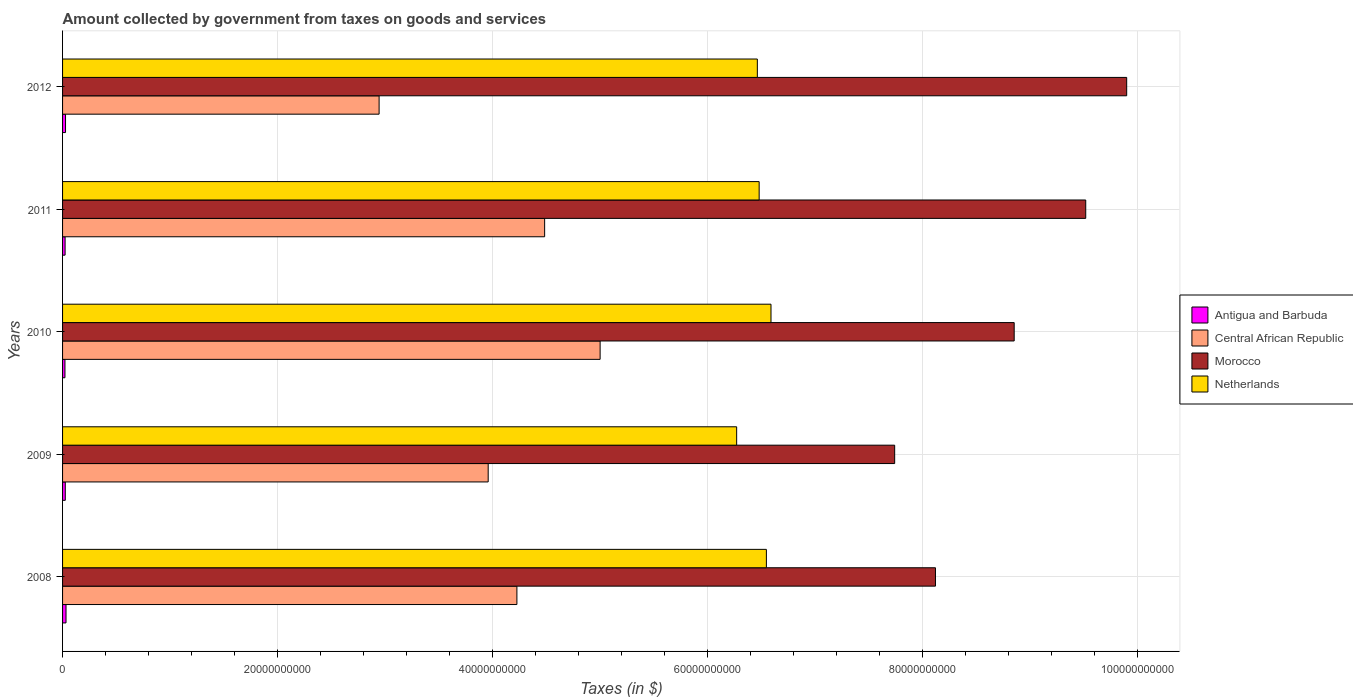How many groups of bars are there?
Make the answer very short. 5. Are the number of bars per tick equal to the number of legend labels?
Provide a succinct answer. Yes. Are the number of bars on each tick of the Y-axis equal?
Provide a short and direct response. Yes. What is the amount collected by government from taxes on goods and services in Antigua and Barbuda in 2009?
Your answer should be compact. 2.53e+08. Across all years, what is the maximum amount collected by government from taxes on goods and services in Netherlands?
Offer a terse response. 6.59e+1. Across all years, what is the minimum amount collected by government from taxes on goods and services in Central African Republic?
Offer a terse response. 2.95e+1. In which year was the amount collected by government from taxes on goods and services in Central African Republic maximum?
Your answer should be very brief. 2010. In which year was the amount collected by government from taxes on goods and services in Netherlands minimum?
Ensure brevity in your answer.  2009. What is the total amount collected by government from taxes on goods and services in Antigua and Barbuda in the graph?
Provide a short and direct response. 1.31e+09. What is the difference between the amount collected by government from taxes on goods and services in Central African Republic in 2009 and that in 2011?
Keep it short and to the point. -5.25e+09. What is the difference between the amount collected by government from taxes on goods and services in Antigua and Barbuda in 2008 and the amount collected by government from taxes on goods and services in Netherlands in 2012?
Your answer should be very brief. -6.43e+1. What is the average amount collected by government from taxes on goods and services in Antigua and Barbuda per year?
Your answer should be very brief. 2.61e+08. In the year 2008, what is the difference between the amount collected by government from taxes on goods and services in Central African Republic and amount collected by government from taxes on goods and services in Antigua and Barbuda?
Make the answer very short. 4.20e+1. In how many years, is the amount collected by government from taxes on goods and services in Central African Republic greater than 12000000000 $?
Provide a succinct answer. 5. What is the ratio of the amount collected by government from taxes on goods and services in Central African Republic in 2008 to that in 2012?
Make the answer very short. 1.44. What is the difference between the highest and the second highest amount collected by government from taxes on goods and services in Antigua and Barbuda?
Give a very brief answer. 4.62e+07. What is the difference between the highest and the lowest amount collected by government from taxes on goods and services in Central African Republic?
Ensure brevity in your answer.  2.06e+1. What does the 1st bar from the top in 2008 represents?
Give a very brief answer. Netherlands. What does the 4th bar from the bottom in 2012 represents?
Your response must be concise. Netherlands. How many bars are there?
Give a very brief answer. 20. Are all the bars in the graph horizontal?
Keep it short and to the point. Yes. How many years are there in the graph?
Offer a terse response. 5. Are the values on the major ticks of X-axis written in scientific E-notation?
Your response must be concise. No. Does the graph contain grids?
Provide a succinct answer. Yes. What is the title of the graph?
Offer a very short reply. Amount collected by government from taxes on goods and services. Does "Cabo Verde" appear as one of the legend labels in the graph?
Provide a succinct answer. No. What is the label or title of the X-axis?
Provide a short and direct response. Taxes (in $). What is the Taxes (in $) in Antigua and Barbuda in 2008?
Offer a very short reply. 3.22e+08. What is the Taxes (in $) in Central African Republic in 2008?
Keep it short and to the point. 4.23e+1. What is the Taxes (in $) in Morocco in 2008?
Keep it short and to the point. 8.12e+1. What is the Taxes (in $) in Netherlands in 2008?
Ensure brevity in your answer.  6.55e+1. What is the Taxes (in $) in Antigua and Barbuda in 2009?
Give a very brief answer. 2.53e+08. What is the Taxes (in $) in Central African Republic in 2009?
Ensure brevity in your answer.  3.96e+1. What is the Taxes (in $) in Morocco in 2009?
Your answer should be very brief. 7.74e+1. What is the Taxes (in $) in Netherlands in 2009?
Give a very brief answer. 6.27e+1. What is the Taxes (in $) of Antigua and Barbuda in 2010?
Your response must be concise. 2.23e+08. What is the Taxes (in $) in Central African Republic in 2010?
Offer a very short reply. 5.00e+1. What is the Taxes (in $) in Morocco in 2010?
Your answer should be compact. 8.86e+1. What is the Taxes (in $) of Netherlands in 2010?
Ensure brevity in your answer.  6.59e+1. What is the Taxes (in $) in Antigua and Barbuda in 2011?
Give a very brief answer. 2.35e+08. What is the Taxes (in $) in Central African Republic in 2011?
Your answer should be very brief. 4.49e+1. What is the Taxes (in $) of Morocco in 2011?
Make the answer very short. 9.52e+1. What is the Taxes (in $) in Netherlands in 2011?
Provide a short and direct response. 6.48e+1. What is the Taxes (in $) of Antigua and Barbuda in 2012?
Your answer should be compact. 2.75e+08. What is the Taxes (in $) in Central African Republic in 2012?
Offer a terse response. 2.95e+1. What is the Taxes (in $) in Morocco in 2012?
Your answer should be compact. 9.90e+1. What is the Taxes (in $) in Netherlands in 2012?
Your response must be concise. 6.47e+1. Across all years, what is the maximum Taxes (in $) of Antigua and Barbuda?
Make the answer very short. 3.22e+08. Across all years, what is the maximum Taxes (in $) in Central African Republic?
Offer a terse response. 5.00e+1. Across all years, what is the maximum Taxes (in $) in Morocco?
Provide a short and direct response. 9.90e+1. Across all years, what is the maximum Taxes (in $) in Netherlands?
Offer a very short reply. 6.59e+1. Across all years, what is the minimum Taxes (in $) of Antigua and Barbuda?
Your response must be concise. 2.23e+08. Across all years, what is the minimum Taxes (in $) in Central African Republic?
Provide a succinct answer. 2.95e+1. Across all years, what is the minimum Taxes (in $) in Morocco?
Your response must be concise. 7.74e+1. Across all years, what is the minimum Taxes (in $) in Netherlands?
Your answer should be compact. 6.27e+1. What is the total Taxes (in $) in Antigua and Barbuda in the graph?
Your response must be concise. 1.31e+09. What is the total Taxes (in $) of Central African Republic in the graph?
Give a very brief answer. 2.06e+11. What is the total Taxes (in $) of Morocco in the graph?
Make the answer very short. 4.42e+11. What is the total Taxes (in $) in Netherlands in the graph?
Offer a terse response. 3.24e+11. What is the difference between the Taxes (in $) of Antigua and Barbuda in 2008 and that in 2009?
Offer a very short reply. 6.90e+07. What is the difference between the Taxes (in $) in Central African Republic in 2008 and that in 2009?
Give a very brief answer. 2.67e+09. What is the difference between the Taxes (in $) of Morocco in 2008 and that in 2009?
Make the answer very short. 3.80e+09. What is the difference between the Taxes (in $) of Netherlands in 2008 and that in 2009?
Provide a short and direct response. 2.77e+09. What is the difference between the Taxes (in $) in Antigua and Barbuda in 2008 and that in 2010?
Give a very brief answer. 9.88e+07. What is the difference between the Taxes (in $) in Central African Republic in 2008 and that in 2010?
Offer a terse response. -7.75e+09. What is the difference between the Taxes (in $) of Morocco in 2008 and that in 2010?
Offer a very short reply. -7.33e+09. What is the difference between the Taxes (in $) in Netherlands in 2008 and that in 2010?
Make the answer very short. -4.29e+08. What is the difference between the Taxes (in $) of Antigua and Barbuda in 2008 and that in 2011?
Ensure brevity in your answer.  8.70e+07. What is the difference between the Taxes (in $) in Central African Republic in 2008 and that in 2011?
Provide a succinct answer. -2.58e+09. What is the difference between the Taxes (in $) of Morocco in 2008 and that in 2011?
Offer a very short reply. -1.40e+1. What is the difference between the Taxes (in $) in Netherlands in 2008 and that in 2011?
Provide a short and direct response. 6.73e+08. What is the difference between the Taxes (in $) in Antigua and Barbuda in 2008 and that in 2012?
Keep it short and to the point. 4.62e+07. What is the difference between the Taxes (in $) of Central African Republic in 2008 and that in 2012?
Offer a terse response. 1.28e+1. What is the difference between the Taxes (in $) in Morocco in 2008 and that in 2012?
Your answer should be compact. -1.78e+1. What is the difference between the Taxes (in $) in Netherlands in 2008 and that in 2012?
Make the answer very short. 8.42e+08. What is the difference between the Taxes (in $) of Antigua and Barbuda in 2009 and that in 2010?
Your response must be concise. 2.98e+07. What is the difference between the Taxes (in $) in Central African Republic in 2009 and that in 2010?
Your answer should be compact. -1.04e+1. What is the difference between the Taxes (in $) of Morocco in 2009 and that in 2010?
Provide a succinct answer. -1.11e+1. What is the difference between the Taxes (in $) in Netherlands in 2009 and that in 2010?
Provide a short and direct response. -3.20e+09. What is the difference between the Taxes (in $) of Antigua and Barbuda in 2009 and that in 2011?
Give a very brief answer. 1.80e+07. What is the difference between the Taxes (in $) in Central African Republic in 2009 and that in 2011?
Provide a succinct answer. -5.25e+09. What is the difference between the Taxes (in $) of Morocco in 2009 and that in 2011?
Ensure brevity in your answer.  -1.78e+1. What is the difference between the Taxes (in $) of Netherlands in 2009 and that in 2011?
Provide a succinct answer. -2.09e+09. What is the difference between the Taxes (in $) in Antigua and Barbuda in 2009 and that in 2012?
Your answer should be very brief. -2.28e+07. What is the difference between the Taxes (in $) in Central African Republic in 2009 and that in 2012?
Provide a succinct answer. 1.02e+1. What is the difference between the Taxes (in $) of Morocco in 2009 and that in 2012?
Make the answer very short. -2.16e+1. What is the difference between the Taxes (in $) in Netherlands in 2009 and that in 2012?
Provide a short and direct response. -1.92e+09. What is the difference between the Taxes (in $) in Antigua and Barbuda in 2010 and that in 2011?
Give a very brief answer. -1.18e+07. What is the difference between the Taxes (in $) in Central African Republic in 2010 and that in 2011?
Your answer should be compact. 5.16e+09. What is the difference between the Taxes (in $) of Morocco in 2010 and that in 2011?
Give a very brief answer. -6.66e+09. What is the difference between the Taxes (in $) in Netherlands in 2010 and that in 2011?
Provide a succinct answer. 1.10e+09. What is the difference between the Taxes (in $) in Antigua and Barbuda in 2010 and that in 2012?
Your answer should be very brief. -5.26e+07. What is the difference between the Taxes (in $) of Central African Republic in 2010 and that in 2012?
Make the answer very short. 2.06e+1. What is the difference between the Taxes (in $) of Morocco in 2010 and that in 2012?
Keep it short and to the point. -1.05e+1. What is the difference between the Taxes (in $) in Netherlands in 2010 and that in 2012?
Offer a terse response. 1.27e+09. What is the difference between the Taxes (in $) in Antigua and Barbuda in 2011 and that in 2012?
Your response must be concise. -4.08e+07. What is the difference between the Taxes (in $) in Central African Republic in 2011 and that in 2012?
Offer a very short reply. 1.54e+1. What is the difference between the Taxes (in $) of Morocco in 2011 and that in 2012?
Offer a terse response. -3.81e+09. What is the difference between the Taxes (in $) of Netherlands in 2011 and that in 2012?
Offer a terse response. 1.69e+08. What is the difference between the Taxes (in $) of Antigua and Barbuda in 2008 and the Taxes (in $) of Central African Republic in 2009?
Ensure brevity in your answer.  -3.93e+1. What is the difference between the Taxes (in $) of Antigua and Barbuda in 2008 and the Taxes (in $) of Morocco in 2009?
Ensure brevity in your answer.  -7.71e+1. What is the difference between the Taxes (in $) of Antigua and Barbuda in 2008 and the Taxes (in $) of Netherlands in 2009?
Keep it short and to the point. -6.24e+1. What is the difference between the Taxes (in $) in Central African Republic in 2008 and the Taxes (in $) in Morocco in 2009?
Provide a short and direct response. -3.52e+1. What is the difference between the Taxes (in $) in Central African Republic in 2008 and the Taxes (in $) in Netherlands in 2009?
Ensure brevity in your answer.  -2.05e+1. What is the difference between the Taxes (in $) of Morocco in 2008 and the Taxes (in $) of Netherlands in 2009?
Keep it short and to the point. 1.85e+1. What is the difference between the Taxes (in $) of Antigua and Barbuda in 2008 and the Taxes (in $) of Central African Republic in 2010?
Make the answer very short. -4.97e+1. What is the difference between the Taxes (in $) in Antigua and Barbuda in 2008 and the Taxes (in $) in Morocco in 2010?
Offer a very short reply. -8.82e+1. What is the difference between the Taxes (in $) in Antigua and Barbuda in 2008 and the Taxes (in $) in Netherlands in 2010?
Give a very brief answer. -6.56e+1. What is the difference between the Taxes (in $) of Central African Republic in 2008 and the Taxes (in $) of Morocco in 2010?
Make the answer very short. -4.63e+1. What is the difference between the Taxes (in $) in Central African Republic in 2008 and the Taxes (in $) in Netherlands in 2010?
Keep it short and to the point. -2.36e+1. What is the difference between the Taxes (in $) of Morocco in 2008 and the Taxes (in $) of Netherlands in 2010?
Your answer should be very brief. 1.53e+1. What is the difference between the Taxes (in $) in Antigua and Barbuda in 2008 and the Taxes (in $) in Central African Republic in 2011?
Your response must be concise. -4.45e+1. What is the difference between the Taxes (in $) of Antigua and Barbuda in 2008 and the Taxes (in $) of Morocco in 2011?
Keep it short and to the point. -9.49e+1. What is the difference between the Taxes (in $) in Antigua and Barbuda in 2008 and the Taxes (in $) in Netherlands in 2011?
Your response must be concise. -6.45e+1. What is the difference between the Taxes (in $) of Central African Republic in 2008 and the Taxes (in $) of Morocco in 2011?
Give a very brief answer. -5.29e+1. What is the difference between the Taxes (in $) in Central African Republic in 2008 and the Taxes (in $) in Netherlands in 2011?
Offer a very short reply. -2.25e+1. What is the difference between the Taxes (in $) of Morocco in 2008 and the Taxes (in $) of Netherlands in 2011?
Provide a short and direct response. 1.64e+1. What is the difference between the Taxes (in $) in Antigua and Barbuda in 2008 and the Taxes (in $) in Central African Republic in 2012?
Provide a short and direct response. -2.91e+1. What is the difference between the Taxes (in $) of Antigua and Barbuda in 2008 and the Taxes (in $) of Morocco in 2012?
Ensure brevity in your answer.  -9.87e+1. What is the difference between the Taxes (in $) of Antigua and Barbuda in 2008 and the Taxes (in $) of Netherlands in 2012?
Ensure brevity in your answer.  -6.43e+1. What is the difference between the Taxes (in $) of Central African Republic in 2008 and the Taxes (in $) of Morocco in 2012?
Offer a terse response. -5.68e+1. What is the difference between the Taxes (in $) of Central African Republic in 2008 and the Taxes (in $) of Netherlands in 2012?
Offer a very short reply. -2.24e+1. What is the difference between the Taxes (in $) of Morocco in 2008 and the Taxes (in $) of Netherlands in 2012?
Your response must be concise. 1.66e+1. What is the difference between the Taxes (in $) of Antigua and Barbuda in 2009 and the Taxes (in $) of Central African Republic in 2010?
Your response must be concise. -4.98e+1. What is the difference between the Taxes (in $) in Antigua and Barbuda in 2009 and the Taxes (in $) in Morocco in 2010?
Keep it short and to the point. -8.83e+1. What is the difference between the Taxes (in $) in Antigua and Barbuda in 2009 and the Taxes (in $) in Netherlands in 2010?
Keep it short and to the point. -6.57e+1. What is the difference between the Taxes (in $) in Central African Republic in 2009 and the Taxes (in $) in Morocco in 2010?
Offer a very short reply. -4.90e+1. What is the difference between the Taxes (in $) in Central African Republic in 2009 and the Taxes (in $) in Netherlands in 2010?
Your response must be concise. -2.63e+1. What is the difference between the Taxes (in $) of Morocco in 2009 and the Taxes (in $) of Netherlands in 2010?
Offer a very short reply. 1.15e+1. What is the difference between the Taxes (in $) of Antigua and Barbuda in 2009 and the Taxes (in $) of Central African Republic in 2011?
Ensure brevity in your answer.  -4.46e+1. What is the difference between the Taxes (in $) in Antigua and Barbuda in 2009 and the Taxes (in $) in Morocco in 2011?
Offer a terse response. -9.50e+1. What is the difference between the Taxes (in $) of Antigua and Barbuda in 2009 and the Taxes (in $) of Netherlands in 2011?
Provide a short and direct response. -6.46e+1. What is the difference between the Taxes (in $) of Central African Republic in 2009 and the Taxes (in $) of Morocco in 2011?
Your answer should be compact. -5.56e+1. What is the difference between the Taxes (in $) in Central African Republic in 2009 and the Taxes (in $) in Netherlands in 2011?
Offer a very short reply. -2.52e+1. What is the difference between the Taxes (in $) of Morocco in 2009 and the Taxes (in $) of Netherlands in 2011?
Offer a terse response. 1.26e+1. What is the difference between the Taxes (in $) in Antigua and Barbuda in 2009 and the Taxes (in $) in Central African Republic in 2012?
Provide a succinct answer. -2.92e+1. What is the difference between the Taxes (in $) in Antigua and Barbuda in 2009 and the Taxes (in $) in Morocco in 2012?
Give a very brief answer. -9.88e+1. What is the difference between the Taxes (in $) in Antigua and Barbuda in 2009 and the Taxes (in $) in Netherlands in 2012?
Give a very brief answer. -6.44e+1. What is the difference between the Taxes (in $) in Central African Republic in 2009 and the Taxes (in $) in Morocco in 2012?
Offer a terse response. -5.94e+1. What is the difference between the Taxes (in $) in Central African Republic in 2009 and the Taxes (in $) in Netherlands in 2012?
Your answer should be compact. -2.51e+1. What is the difference between the Taxes (in $) in Morocco in 2009 and the Taxes (in $) in Netherlands in 2012?
Make the answer very short. 1.28e+1. What is the difference between the Taxes (in $) of Antigua and Barbuda in 2010 and the Taxes (in $) of Central African Republic in 2011?
Your answer should be compact. -4.46e+1. What is the difference between the Taxes (in $) of Antigua and Barbuda in 2010 and the Taxes (in $) of Morocco in 2011?
Give a very brief answer. -9.50e+1. What is the difference between the Taxes (in $) of Antigua and Barbuda in 2010 and the Taxes (in $) of Netherlands in 2011?
Give a very brief answer. -6.46e+1. What is the difference between the Taxes (in $) of Central African Republic in 2010 and the Taxes (in $) of Morocco in 2011?
Provide a short and direct response. -4.52e+1. What is the difference between the Taxes (in $) of Central African Republic in 2010 and the Taxes (in $) of Netherlands in 2011?
Provide a succinct answer. -1.48e+1. What is the difference between the Taxes (in $) in Morocco in 2010 and the Taxes (in $) in Netherlands in 2011?
Give a very brief answer. 2.37e+1. What is the difference between the Taxes (in $) in Antigua and Barbuda in 2010 and the Taxes (in $) in Central African Republic in 2012?
Your answer should be very brief. -2.92e+1. What is the difference between the Taxes (in $) of Antigua and Barbuda in 2010 and the Taxes (in $) of Morocco in 2012?
Your answer should be very brief. -9.88e+1. What is the difference between the Taxes (in $) of Antigua and Barbuda in 2010 and the Taxes (in $) of Netherlands in 2012?
Your answer should be compact. -6.44e+1. What is the difference between the Taxes (in $) of Central African Republic in 2010 and the Taxes (in $) of Morocco in 2012?
Offer a terse response. -4.90e+1. What is the difference between the Taxes (in $) of Central African Republic in 2010 and the Taxes (in $) of Netherlands in 2012?
Your response must be concise. -1.46e+1. What is the difference between the Taxes (in $) in Morocco in 2010 and the Taxes (in $) in Netherlands in 2012?
Give a very brief answer. 2.39e+1. What is the difference between the Taxes (in $) in Antigua and Barbuda in 2011 and the Taxes (in $) in Central African Republic in 2012?
Your answer should be compact. -2.92e+1. What is the difference between the Taxes (in $) in Antigua and Barbuda in 2011 and the Taxes (in $) in Morocco in 2012?
Make the answer very short. -9.88e+1. What is the difference between the Taxes (in $) in Antigua and Barbuda in 2011 and the Taxes (in $) in Netherlands in 2012?
Offer a terse response. -6.44e+1. What is the difference between the Taxes (in $) in Central African Republic in 2011 and the Taxes (in $) in Morocco in 2012?
Give a very brief answer. -5.42e+1. What is the difference between the Taxes (in $) of Central African Republic in 2011 and the Taxes (in $) of Netherlands in 2012?
Your answer should be very brief. -1.98e+1. What is the difference between the Taxes (in $) in Morocco in 2011 and the Taxes (in $) in Netherlands in 2012?
Your answer should be compact. 3.06e+1. What is the average Taxes (in $) in Antigua and Barbuda per year?
Ensure brevity in your answer.  2.61e+08. What is the average Taxes (in $) in Central African Republic per year?
Provide a succinct answer. 4.13e+1. What is the average Taxes (in $) in Morocco per year?
Offer a very short reply. 8.83e+1. What is the average Taxes (in $) of Netherlands per year?
Provide a succinct answer. 6.47e+1. In the year 2008, what is the difference between the Taxes (in $) in Antigua and Barbuda and Taxes (in $) in Central African Republic?
Provide a short and direct response. -4.20e+1. In the year 2008, what is the difference between the Taxes (in $) of Antigua and Barbuda and Taxes (in $) of Morocco?
Your response must be concise. -8.09e+1. In the year 2008, what is the difference between the Taxes (in $) in Antigua and Barbuda and Taxes (in $) in Netherlands?
Your response must be concise. -6.52e+1. In the year 2008, what is the difference between the Taxes (in $) of Central African Republic and Taxes (in $) of Morocco?
Your response must be concise. -3.90e+1. In the year 2008, what is the difference between the Taxes (in $) of Central African Republic and Taxes (in $) of Netherlands?
Make the answer very short. -2.32e+1. In the year 2008, what is the difference between the Taxes (in $) of Morocco and Taxes (in $) of Netherlands?
Give a very brief answer. 1.57e+1. In the year 2009, what is the difference between the Taxes (in $) in Antigua and Barbuda and Taxes (in $) in Central African Republic?
Provide a short and direct response. -3.94e+1. In the year 2009, what is the difference between the Taxes (in $) in Antigua and Barbuda and Taxes (in $) in Morocco?
Make the answer very short. -7.72e+1. In the year 2009, what is the difference between the Taxes (in $) in Antigua and Barbuda and Taxes (in $) in Netherlands?
Your answer should be compact. -6.25e+1. In the year 2009, what is the difference between the Taxes (in $) of Central African Republic and Taxes (in $) of Morocco?
Give a very brief answer. -3.78e+1. In the year 2009, what is the difference between the Taxes (in $) of Central African Republic and Taxes (in $) of Netherlands?
Your response must be concise. -2.31e+1. In the year 2009, what is the difference between the Taxes (in $) in Morocco and Taxes (in $) in Netherlands?
Your answer should be very brief. 1.47e+1. In the year 2010, what is the difference between the Taxes (in $) of Antigua and Barbuda and Taxes (in $) of Central African Republic?
Ensure brevity in your answer.  -4.98e+1. In the year 2010, what is the difference between the Taxes (in $) of Antigua and Barbuda and Taxes (in $) of Morocco?
Provide a short and direct response. -8.83e+1. In the year 2010, what is the difference between the Taxes (in $) of Antigua and Barbuda and Taxes (in $) of Netherlands?
Ensure brevity in your answer.  -6.57e+1. In the year 2010, what is the difference between the Taxes (in $) of Central African Republic and Taxes (in $) of Morocco?
Provide a succinct answer. -3.85e+1. In the year 2010, what is the difference between the Taxes (in $) of Central African Republic and Taxes (in $) of Netherlands?
Offer a very short reply. -1.59e+1. In the year 2010, what is the difference between the Taxes (in $) of Morocco and Taxes (in $) of Netherlands?
Provide a short and direct response. 2.26e+1. In the year 2011, what is the difference between the Taxes (in $) of Antigua and Barbuda and Taxes (in $) of Central African Republic?
Keep it short and to the point. -4.46e+1. In the year 2011, what is the difference between the Taxes (in $) of Antigua and Barbuda and Taxes (in $) of Morocco?
Your answer should be compact. -9.50e+1. In the year 2011, what is the difference between the Taxes (in $) in Antigua and Barbuda and Taxes (in $) in Netherlands?
Make the answer very short. -6.46e+1. In the year 2011, what is the difference between the Taxes (in $) in Central African Republic and Taxes (in $) in Morocco?
Your response must be concise. -5.04e+1. In the year 2011, what is the difference between the Taxes (in $) of Central African Republic and Taxes (in $) of Netherlands?
Offer a terse response. -2.00e+1. In the year 2011, what is the difference between the Taxes (in $) of Morocco and Taxes (in $) of Netherlands?
Your answer should be very brief. 3.04e+1. In the year 2012, what is the difference between the Taxes (in $) of Antigua and Barbuda and Taxes (in $) of Central African Republic?
Your answer should be very brief. -2.92e+1. In the year 2012, what is the difference between the Taxes (in $) in Antigua and Barbuda and Taxes (in $) in Morocco?
Keep it short and to the point. -9.88e+1. In the year 2012, what is the difference between the Taxes (in $) in Antigua and Barbuda and Taxes (in $) in Netherlands?
Provide a short and direct response. -6.44e+1. In the year 2012, what is the difference between the Taxes (in $) in Central African Republic and Taxes (in $) in Morocco?
Offer a terse response. -6.96e+1. In the year 2012, what is the difference between the Taxes (in $) in Central African Republic and Taxes (in $) in Netherlands?
Provide a succinct answer. -3.52e+1. In the year 2012, what is the difference between the Taxes (in $) in Morocco and Taxes (in $) in Netherlands?
Your response must be concise. 3.44e+1. What is the ratio of the Taxes (in $) of Antigua and Barbuda in 2008 to that in 2009?
Provide a short and direct response. 1.27. What is the ratio of the Taxes (in $) of Central African Republic in 2008 to that in 2009?
Your answer should be very brief. 1.07. What is the ratio of the Taxes (in $) in Morocco in 2008 to that in 2009?
Your response must be concise. 1.05. What is the ratio of the Taxes (in $) in Netherlands in 2008 to that in 2009?
Your response must be concise. 1.04. What is the ratio of the Taxes (in $) in Antigua and Barbuda in 2008 to that in 2010?
Your response must be concise. 1.44. What is the ratio of the Taxes (in $) in Central African Republic in 2008 to that in 2010?
Provide a succinct answer. 0.85. What is the ratio of the Taxes (in $) of Morocco in 2008 to that in 2010?
Keep it short and to the point. 0.92. What is the ratio of the Taxes (in $) in Antigua and Barbuda in 2008 to that in 2011?
Offer a terse response. 1.37. What is the ratio of the Taxes (in $) of Central African Republic in 2008 to that in 2011?
Ensure brevity in your answer.  0.94. What is the ratio of the Taxes (in $) in Morocco in 2008 to that in 2011?
Provide a short and direct response. 0.85. What is the ratio of the Taxes (in $) in Netherlands in 2008 to that in 2011?
Keep it short and to the point. 1.01. What is the ratio of the Taxes (in $) of Antigua and Barbuda in 2008 to that in 2012?
Ensure brevity in your answer.  1.17. What is the ratio of the Taxes (in $) of Central African Republic in 2008 to that in 2012?
Your response must be concise. 1.44. What is the ratio of the Taxes (in $) of Morocco in 2008 to that in 2012?
Provide a short and direct response. 0.82. What is the ratio of the Taxes (in $) in Netherlands in 2008 to that in 2012?
Offer a very short reply. 1.01. What is the ratio of the Taxes (in $) in Antigua and Barbuda in 2009 to that in 2010?
Ensure brevity in your answer.  1.13. What is the ratio of the Taxes (in $) of Central African Republic in 2009 to that in 2010?
Provide a succinct answer. 0.79. What is the ratio of the Taxes (in $) of Morocco in 2009 to that in 2010?
Your response must be concise. 0.87. What is the ratio of the Taxes (in $) of Netherlands in 2009 to that in 2010?
Provide a short and direct response. 0.95. What is the ratio of the Taxes (in $) of Antigua and Barbuda in 2009 to that in 2011?
Offer a terse response. 1.08. What is the ratio of the Taxes (in $) of Central African Republic in 2009 to that in 2011?
Provide a succinct answer. 0.88. What is the ratio of the Taxes (in $) of Morocco in 2009 to that in 2011?
Keep it short and to the point. 0.81. What is the ratio of the Taxes (in $) of Netherlands in 2009 to that in 2011?
Provide a succinct answer. 0.97. What is the ratio of the Taxes (in $) in Antigua and Barbuda in 2009 to that in 2012?
Keep it short and to the point. 0.92. What is the ratio of the Taxes (in $) of Central African Republic in 2009 to that in 2012?
Provide a succinct answer. 1.34. What is the ratio of the Taxes (in $) in Morocco in 2009 to that in 2012?
Make the answer very short. 0.78. What is the ratio of the Taxes (in $) of Netherlands in 2009 to that in 2012?
Your answer should be very brief. 0.97. What is the ratio of the Taxes (in $) of Antigua and Barbuda in 2010 to that in 2011?
Offer a very short reply. 0.95. What is the ratio of the Taxes (in $) in Central African Republic in 2010 to that in 2011?
Keep it short and to the point. 1.12. What is the ratio of the Taxes (in $) of Morocco in 2010 to that in 2011?
Your response must be concise. 0.93. What is the ratio of the Taxes (in $) in Antigua and Barbuda in 2010 to that in 2012?
Your answer should be very brief. 0.81. What is the ratio of the Taxes (in $) of Central African Republic in 2010 to that in 2012?
Offer a very short reply. 1.7. What is the ratio of the Taxes (in $) in Morocco in 2010 to that in 2012?
Keep it short and to the point. 0.89. What is the ratio of the Taxes (in $) in Netherlands in 2010 to that in 2012?
Your answer should be compact. 1.02. What is the ratio of the Taxes (in $) of Antigua and Barbuda in 2011 to that in 2012?
Offer a terse response. 0.85. What is the ratio of the Taxes (in $) of Central African Republic in 2011 to that in 2012?
Offer a terse response. 1.52. What is the ratio of the Taxes (in $) in Morocco in 2011 to that in 2012?
Keep it short and to the point. 0.96. What is the difference between the highest and the second highest Taxes (in $) in Antigua and Barbuda?
Ensure brevity in your answer.  4.62e+07. What is the difference between the highest and the second highest Taxes (in $) in Central African Republic?
Your answer should be compact. 5.16e+09. What is the difference between the highest and the second highest Taxes (in $) of Morocco?
Provide a succinct answer. 3.81e+09. What is the difference between the highest and the second highest Taxes (in $) in Netherlands?
Provide a succinct answer. 4.29e+08. What is the difference between the highest and the lowest Taxes (in $) in Antigua and Barbuda?
Your answer should be compact. 9.88e+07. What is the difference between the highest and the lowest Taxes (in $) in Central African Republic?
Offer a terse response. 2.06e+1. What is the difference between the highest and the lowest Taxes (in $) of Morocco?
Provide a short and direct response. 2.16e+1. What is the difference between the highest and the lowest Taxes (in $) in Netherlands?
Provide a succinct answer. 3.20e+09. 